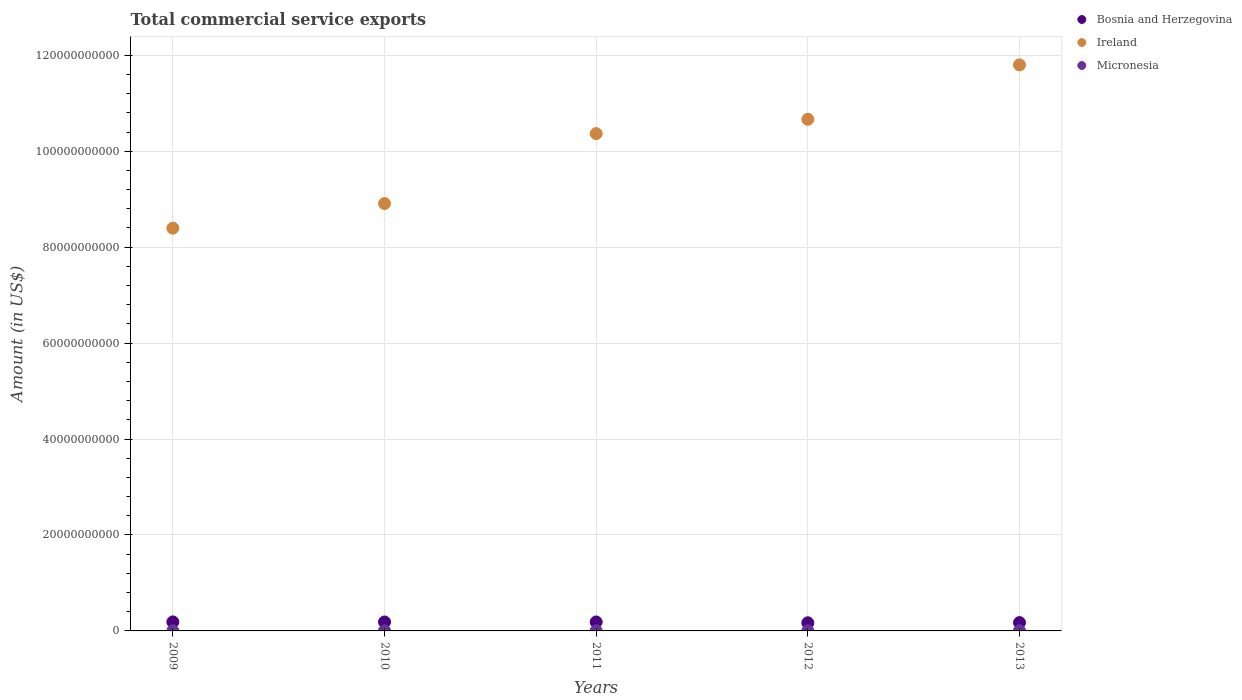How many different coloured dotlines are there?
Provide a succinct answer. 3. Is the number of dotlines equal to the number of legend labels?
Keep it short and to the point. Yes. What is the total commercial service exports in Bosnia and Herzegovina in 2010?
Your answer should be very brief. 1.86e+09. Across all years, what is the maximum total commercial service exports in Bosnia and Herzegovina?
Make the answer very short. 1.88e+09. Across all years, what is the minimum total commercial service exports in Micronesia?
Ensure brevity in your answer.  3.13e+07. What is the total total commercial service exports in Bosnia and Herzegovina in the graph?
Ensure brevity in your answer.  9.04e+09. What is the difference between the total commercial service exports in Bosnia and Herzegovina in 2009 and that in 2011?
Provide a short and direct response. 1.30e+07. What is the difference between the total commercial service exports in Bosnia and Herzegovina in 2009 and the total commercial service exports in Ireland in 2010?
Your response must be concise. -8.72e+1. What is the average total commercial service exports in Ireland per year?
Give a very brief answer. 1.00e+11. In the year 2012, what is the difference between the total commercial service exports in Micronesia and total commercial service exports in Bosnia and Herzegovina?
Your answer should be compact. -1.66e+09. In how many years, is the total commercial service exports in Ireland greater than 92000000000 US$?
Provide a short and direct response. 3. What is the ratio of the total commercial service exports in Ireland in 2012 to that in 2013?
Your response must be concise. 0.9. Is the total commercial service exports in Micronesia in 2010 less than that in 2011?
Your answer should be compact. No. Is the difference between the total commercial service exports in Micronesia in 2010 and 2012 greater than the difference between the total commercial service exports in Bosnia and Herzegovina in 2010 and 2012?
Give a very brief answer. No. What is the difference between the highest and the second highest total commercial service exports in Micronesia?
Offer a very short reply. 9.83e+05. What is the difference between the highest and the lowest total commercial service exports in Ireland?
Make the answer very short. 3.40e+1. In how many years, is the total commercial service exports in Micronesia greater than the average total commercial service exports in Micronesia taken over all years?
Your answer should be compact. 3. Is it the case that in every year, the sum of the total commercial service exports in Micronesia and total commercial service exports in Ireland  is greater than the total commercial service exports in Bosnia and Herzegovina?
Offer a very short reply. Yes. Is the total commercial service exports in Micronesia strictly greater than the total commercial service exports in Bosnia and Herzegovina over the years?
Your answer should be compact. No. How many years are there in the graph?
Your answer should be compact. 5. What is the difference between two consecutive major ticks on the Y-axis?
Provide a succinct answer. 2.00e+1. Are the values on the major ticks of Y-axis written in scientific E-notation?
Your response must be concise. No. Does the graph contain any zero values?
Your answer should be compact. No. Does the graph contain grids?
Your answer should be compact. Yes. What is the title of the graph?
Give a very brief answer. Total commercial service exports. What is the label or title of the X-axis?
Keep it short and to the point. Years. What is the Amount (in US$) of Bosnia and Herzegovina in 2009?
Provide a succinct answer. 1.88e+09. What is the Amount (in US$) in Ireland in 2009?
Your response must be concise. 8.40e+1. What is the Amount (in US$) in Micronesia in 2009?
Your answer should be very brief. 3.21e+07. What is the Amount (in US$) in Bosnia and Herzegovina in 2010?
Your answer should be compact. 1.86e+09. What is the Amount (in US$) in Ireland in 2010?
Provide a succinct answer. 8.91e+1. What is the Amount (in US$) in Micronesia in 2010?
Offer a very short reply. 3.50e+07. What is the Amount (in US$) in Bosnia and Herzegovina in 2011?
Your answer should be very brief. 1.87e+09. What is the Amount (in US$) in Ireland in 2011?
Provide a short and direct response. 1.04e+11. What is the Amount (in US$) of Micronesia in 2011?
Ensure brevity in your answer.  3.13e+07. What is the Amount (in US$) of Bosnia and Herzegovina in 2012?
Your response must be concise. 1.69e+09. What is the Amount (in US$) in Ireland in 2012?
Offer a terse response. 1.07e+11. What is the Amount (in US$) of Micronesia in 2012?
Offer a terse response. 3.40e+07. What is the Amount (in US$) of Bosnia and Herzegovina in 2013?
Give a very brief answer. 1.74e+09. What is the Amount (in US$) in Ireland in 2013?
Make the answer very short. 1.18e+11. What is the Amount (in US$) of Micronesia in 2013?
Your answer should be very brief. 3.59e+07. Across all years, what is the maximum Amount (in US$) in Bosnia and Herzegovina?
Offer a very short reply. 1.88e+09. Across all years, what is the maximum Amount (in US$) in Ireland?
Make the answer very short. 1.18e+11. Across all years, what is the maximum Amount (in US$) of Micronesia?
Ensure brevity in your answer.  3.59e+07. Across all years, what is the minimum Amount (in US$) of Bosnia and Herzegovina?
Provide a short and direct response. 1.69e+09. Across all years, what is the minimum Amount (in US$) of Ireland?
Ensure brevity in your answer.  8.40e+1. Across all years, what is the minimum Amount (in US$) of Micronesia?
Make the answer very short. 3.13e+07. What is the total Amount (in US$) of Bosnia and Herzegovina in the graph?
Make the answer very short. 9.04e+09. What is the total Amount (in US$) of Ireland in the graph?
Your answer should be very brief. 5.01e+11. What is the total Amount (in US$) in Micronesia in the graph?
Give a very brief answer. 1.68e+08. What is the difference between the Amount (in US$) of Bosnia and Herzegovina in 2009 and that in 2010?
Provide a succinct answer. 2.00e+07. What is the difference between the Amount (in US$) in Ireland in 2009 and that in 2010?
Your response must be concise. -5.14e+09. What is the difference between the Amount (in US$) in Micronesia in 2009 and that in 2010?
Your answer should be compact. -2.88e+06. What is the difference between the Amount (in US$) in Bosnia and Herzegovina in 2009 and that in 2011?
Provide a succinct answer. 1.30e+07. What is the difference between the Amount (in US$) in Ireland in 2009 and that in 2011?
Provide a short and direct response. -1.97e+1. What is the difference between the Amount (in US$) of Micronesia in 2009 and that in 2011?
Your answer should be compact. 8.24e+05. What is the difference between the Amount (in US$) in Bosnia and Herzegovina in 2009 and that in 2012?
Give a very brief answer. 1.86e+08. What is the difference between the Amount (in US$) in Ireland in 2009 and that in 2012?
Give a very brief answer. -2.27e+1. What is the difference between the Amount (in US$) in Micronesia in 2009 and that in 2012?
Your answer should be very brief. -1.88e+06. What is the difference between the Amount (in US$) in Bosnia and Herzegovina in 2009 and that in 2013?
Your answer should be compact. 1.43e+08. What is the difference between the Amount (in US$) of Ireland in 2009 and that in 2013?
Provide a short and direct response. -3.40e+1. What is the difference between the Amount (in US$) of Micronesia in 2009 and that in 2013?
Ensure brevity in your answer.  -3.86e+06. What is the difference between the Amount (in US$) of Bosnia and Herzegovina in 2010 and that in 2011?
Keep it short and to the point. -7.01e+06. What is the difference between the Amount (in US$) in Ireland in 2010 and that in 2011?
Keep it short and to the point. -1.46e+1. What is the difference between the Amount (in US$) of Micronesia in 2010 and that in 2011?
Provide a succinct answer. 3.70e+06. What is the difference between the Amount (in US$) of Bosnia and Herzegovina in 2010 and that in 2012?
Your answer should be very brief. 1.66e+08. What is the difference between the Amount (in US$) of Ireland in 2010 and that in 2012?
Ensure brevity in your answer.  -1.76e+1. What is the difference between the Amount (in US$) in Micronesia in 2010 and that in 2012?
Offer a terse response. 9.99e+05. What is the difference between the Amount (in US$) of Bosnia and Herzegovina in 2010 and that in 2013?
Offer a very short reply. 1.23e+08. What is the difference between the Amount (in US$) of Ireland in 2010 and that in 2013?
Provide a short and direct response. -2.89e+1. What is the difference between the Amount (in US$) in Micronesia in 2010 and that in 2013?
Your answer should be very brief. -9.83e+05. What is the difference between the Amount (in US$) in Bosnia and Herzegovina in 2011 and that in 2012?
Ensure brevity in your answer.  1.73e+08. What is the difference between the Amount (in US$) of Ireland in 2011 and that in 2012?
Provide a short and direct response. -2.98e+09. What is the difference between the Amount (in US$) in Micronesia in 2011 and that in 2012?
Your answer should be compact. -2.70e+06. What is the difference between the Amount (in US$) of Bosnia and Herzegovina in 2011 and that in 2013?
Give a very brief answer. 1.30e+08. What is the difference between the Amount (in US$) in Ireland in 2011 and that in 2013?
Ensure brevity in your answer.  -1.43e+1. What is the difference between the Amount (in US$) of Micronesia in 2011 and that in 2013?
Provide a short and direct response. -4.68e+06. What is the difference between the Amount (in US$) in Bosnia and Herzegovina in 2012 and that in 2013?
Keep it short and to the point. -4.32e+07. What is the difference between the Amount (in US$) of Ireland in 2012 and that in 2013?
Make the answer very short. -1.13e+1. What is the difference between the Amount (in US$) in Micronesia in 2012 and that in 2013?
Provide a succinct answer. -1.98e+06. What is the difference between the Amount (in US$) of Bosnia and Herzegovina in 2009 and the Amount (in US$) of Ireland in 2010?
Offer a terse response. -8.72e+1. What is the difference between the Amount (in US$) in Bosnia and Herzegovina in 2009 and the Amount (in US$) in Micronesia in 2010?
Provide a succinct answer. 1.85e+09. What is the difference between the Amount (in US$) of Ireland in 2009 and the Amount (in US$) of Micronesia in 2010?
Make the answer very short. 8.39e+1. What is the difference between the Amount (in US$) of Bosnia and Herzegovina in 2009 and the Amount (in US$) of Ireland in 2011?
Your answer should be compact. -1.02e+11. What is the difference between the Amount (in US$) in Bosnia and Herzegovina in 2009 and the Amount (in US$) in Micronesia in 2011?
Keep it short and to the point. 1.85e+09. What is the difference between the Amount (in US$) in Ireland in 2009 and the Amount (in US$) in Micronesia in 2011?
Offer a very short reply. 8.39e+1. What is the difference between the Amount (in US$) of Bosnia and Herzegovina in 2009 and the Amount (in US$) of Ireland in 2012?
Give a very brief answer. -1.05e+11. What is the difference between the Amount (in US$) in Bosnia and Herzegovina in 2009 and the Amount (in US$) in Micronesia in 2012?
Offer a terse response. 1.85e+09. What is the difference between the Amount (in US$) of Ireland in 2009 and the Amount (in US$) of Micronesia in 2012?
Make the answer very short. 8.39e+1. What is the difference between the Amount (in US$) in Bosnia and Herzegovina in 2009 and the Amount (in US$) in Ireland in 2013?
Offer a terse response. -1.16e+11. What is the difference between the Amount (in US$) of Bosnia and Herzegovina in 2009 and the Amount (in US$) of Micronesia in 2013?
Make the answer very short. 1.84e+09. What is the difference between the Amount (in US$) of Ireland in 2009 and the Amount (in US$) of Micronesia in 2013?
Your answer should be very brief. 8.39e+1. What is the difference between the Amount (in US$) in Bosnia and Herzegovina in 2010 and the Amount (in US$) in Ireland in 2011?
Offer a terse response. -1.02e+11. What is the difference between the Amount (in US$) of Bosnia and Herzegovina in 2010 and the Amount (in US$) of Micronesia in 2011?
Provide a succinct answer. 1.83e+09. What is the difference between the Amount (in US$) in Ireland in 2010 and the Amount (in US$) in Micronesia in 2011?
Your answer should be very brief. 8.91e+1. What is the difference between the Amount (in US$) of Bosnia and Herzegovina in 2010 and the Amount (in US$) of Ireland in 2012?
Your response must be concise. -1.05e+11. What is the difference between the Amount (in US$) of Bosnia and Herzegovina in 2010 and the Amount (in US$) of Micronesia in 2012?
Give a very brief answer. 1.83e+09. What is the difference between the Amount (in US$) of Ireland in 2010 and the Amount (in US$) of Micronesia in 2012?
Your answer should be very brief. 8.91e+1. What is the difference between the Amount (in US$) in Bosnia and Herzegovina in 2010 and the Amount (in US$) in Ireland in 2013?
Provide a short and direct response. -1.16e+11. What is the difference between the Amount (in US$) of Bosnia and Herzegovina in 2010 and the Amount (in US$) of Micronesia in 2013?
Offer a very short reply. 1.82e+09. What is the difference between the Amount (in US$) in Ireland in 2010 and the Amount (in US$) in Micronesia in 2013?
Keep it short and to the point. 8.91e+1. What is the difference between the Amount (in US$) of Bosnia and Herzegovina in 2011 and the Amount (in US$) of Ireland in 2012?
Provide a succinct answer. -1.05e+11. What is the difference between the Amount (in US$) in Bosnia and Herzegovina in 2011 and the Amount (in US$) in Micronesia in 2012?
Your answer should be compact. 1.83e+09. What is the difference between the Amount (in US$) of Ireland in 2011 and the Amount (in US$) of Micronesia in 2012?
Your answer should be very brief. 1.04e+11. What is the difference between the Amount (in US$) in Bosnia and Herzegovina in 2011 and the Amount (in US$) in Ireland in 2013?
Ensure brevity in your answer.  -1.16e+11. What is the difference between the Amount (in US$) of Bosnia and Herzegovina in 2011 and the Amount (in US$) of Micronesia in 2013?
Ensure brevity in your answer.  1.83e+09. What is the difference between the Amount (in US$) of Ireland in 2011 and the Amount (in US$) of Micronesia in 2013?
Give a very brief answer. 1.04e+11. What is the difference between the Amount (in US$) of Bosnia and Herzegovina in 2012 and the Amount (in US$) of Ireland in 2013?
Your answer should be compact. -1.16e+11. What is the difference between the Amount (in US$) in Bosnia and Herzegovina in 2012 and the Amount (in US$) in Micronesia in 2013?
Keep it short and to the point. 1.66e+09. What is the difference between the Amount (in US$) in Ireland in 2012 and the Amount (in US$) in Micronesia in 2013?
Your answer should be compact. 1.07e+11. What is the average Amount (in US$) in Bosnia and Herzegovina per year?
Your answer should be compact. 1.81e+09. What is the average Amount (in US$) of Ireland per year?
Your response must be concise. 1.00e+11. What is the average Amount (in US$) of Micronesia per year?
Your answer should be very brief. 3.36e+07. In the year 2009, what is the difference between the Amount (in US$) in Bosnia and Herzegovina and Amount (in US$) in Ireland?
Make the answer very short. -8.21e+1. In the year 2009, what is the difference between the Amount (in US$) in Bosnia and Herzegovina and Amount (in US$) in Micronesia?
Your response must be concise. 1.85e+09. In the year 2009, what is the difference between the Amount (in US$) in Ireland and Amount (in US$) in Micronesia?
Your response must be concise. 8.39e+1. In the year 2010, what is the difference between the Amount (in US$) in Bosnia and Herzegovina and Amount (in US$) in Ireland?
Keep it short and to the point. -8.72e+1. In the year 2010, what is the difference between the Amount (in US$) in Bosnia and Herzegovina and Amount (in US$) in Micronesia?
Your answer should be very brief. 1.83e+09. In the year 2010, what is the difference between the Amount (in US$) of Ireland and Amount (in US$) of Micronesia?
Your answer should be very brief. 8.91e+1. In the year 2011, what is the difference between the Amount (in US$) of Bosnia and Herzegovina and Amount (in US$) of Ireland?
Provide a short and direct response. -1.02e+11. In the year 2011, what is the difference between the Amount (in US$) of Bosnia and Herzegovina and Amount (in US$) of Micronesia?
Provide a short and direct response. 1.84e+09. In the year 2011, what is the difference between the Amount (in US$) of Ireland and Amount (in US$) of Micronesia?
Offer a very short reply. 1.04e+11. In the year 2012, what is the difference between the Amount (in US$) in Bosnia and Herzegovina and Amount (in US$) in Ireland?
Make the answer very short. -1.05e+11. In the year 2012, what is the difference between the Amount (in US$) in Bosnia and Herzegovina and Amount (in US$) in Micronesia?
Your response must be concise. 1.66e+09. In the year 2012, what is the difference between the Amount (in US$) in Ireland and Amount (in US$) in Micronesia?
Provide a short and direct response. 1.07e+11. In the year 2013, what is the difference between the Amount (in US$) of Bosnia and Herzegovina and Amount (in US$) of Ireland?
Your response must be concise. -1.16e+11. In the year 2013, what is the difference between the Amount (in US$) of Bosnia and Herzegovina and Amount (in US$) of Micronesia?
Ensure brevity in your answer.  1.70e+09. In the year 2013, what is the difference between the Amount (in US$) in Ireland and Amount (in US$) in Micronesia?
Your answer should be very brief. 1.18e+11. What is the ratio of the Amount (in US$) in Bosnia and Herzegovina in 2009 to that in 2010?
Provide a succinct answer. 1.01. What is the ratio of the Amount (in US$) of Ireland in 2009 to that in 2010?
Your answer should be very brief. 0.94. What is the ratio of the Amount (in US$) of Micronesia in 2009 to that in 2010?
Your answer should be very brief. 0.92. What is the ratio of the Amount (in US$) in Ireland in 2009 to that in 2011?
Offer a terse response. 0.81. What is the ratio of the Amount (in US$) in Micronesia in 2009 to that in 2011?
Give a very brief answer. 1.03. What is the ratio of the Amount (in US$) in Bosnia and Herzegovina in 2009 to that in 2012?
Your answer should be very brief. 1.11. What is the ratio of the Amount (in US$) in Ireland in 2009 to that in 2012?
Ensure brevity in your answer.  0.79. What is the ratio of the Amount (in US$) of Micronesia in 2009 to that in 2012?
Provide a short and direct response. 0.94. What is the ratio of the Amount (in US$) in Bosnia and Herzegovina in 2009 to that in 2013?
Provide a succinct answer. 1.08. What is the ratio of the Amount (in US$) of Ireland in 2009 to that in 2013?
Your response must be concise. 0.71. What is the ratio of the Amount (in US$) of Micronesia in 2009 to that in 2013?
Your answer should be compact. 0.89. What is the ratio of the Amount (in US$) of Ireland in 2010 to that in 2011?
Provide a short and direct response. 0.86. What is the ratio of the Amount (in US$) in Micronesia in 2010 to that in 2011?
Make the answer very short. 1.12. What is the ratio of the Amount (in US$) of Bosnia and Herzegovina in 2010 to that in 2012?
Provide a short and direct response. 1.1. What is the ratio of the Amount (in US$) in Ireland in 2010 to that in 2012?
Keep it short and to the point. 0.84. What is the ratio of the Amount (in US$) in Micronesia in 2010 to that in 2012?
Provide a succinct answer. 1.03. What is the ratio of the Amount (in US$) in Bosnia and Herzegovina in 2010 to that in 2013?
Offer a terse response. 1.07. What is the ratio of the Amount (in US$) of Ireland in 2010 to that in 2013?
Provide a short and direct response. 0.76. What is the ratio of the Amount (in US$) of Micronesia in 2010 to that in 2013?
Your response must be concise. 0.97. What is the ratio of the Amount (in US$) of Bosnia and Herzegovina in 2011 to that in 2012?
Keep it short and to the point. 1.1. What is the ratio of the Amount (in US$) of Ireland in 2011 to that in 2012?
Offer a terse response. 0.97. What is the ratio of the Amount (in US$) in Micronesia in 2011 to that in 2012?
Provide a succinct answer. 0.92. What is the ratio of the Amount (in US$) in Bosnia and Herzegovina in 2011 to that in 2013?
Your answer should be very brief. 1.07. What is the ratio of the Amount (in US$) of Ireland in 2011 to that in 2013?
Keep it short and to the point. 0.88. What is the ratio of the Amount (in US$) in Micronesia in 2011 to that in 2013?
Your answer should be compact. 0.87. What is the ratio of the Amount (in US$) of Bosnia and Herzegovina in 2012 to that in 2013?
Make the answer very short. 0.98. What is the ratio of the Amount (in US$) of Ireland in 2012 to that in 2013?
Your answer should be very brief. 0.9. What is the ratio of the Amount (in US$) of Micronesia in 2012 to that in 2013?
Your answer should be very brief. 0.94. What is the difference between the highest and the second highest Amount (in US$) in Bosnia and Herzegovina?
Ensure brevity in your answer.  1.30e+07. What is the difference between the highest and the second highest Amount (in US$) in Ireland?
Provide a succinct answer. 1.13e+1. What is the difference between the highest and the second highest Amount (in US$) in Micronesia?
Provide a succinct answer. 9.83e+05. What is the difference between the highest and the lowest Amount (in US$) of Bosnia and Herzegovina?
Make the answer very short. 1.86e+08. What is the difference between the highest and the lowest Amount (in US$) in Ireland?
Your response must be concise. 3.40e+1. What is the difference between the highest and the lowest Amount (in US$) in Micronesia?
Provide a short and direct response. 4.68e+06. 